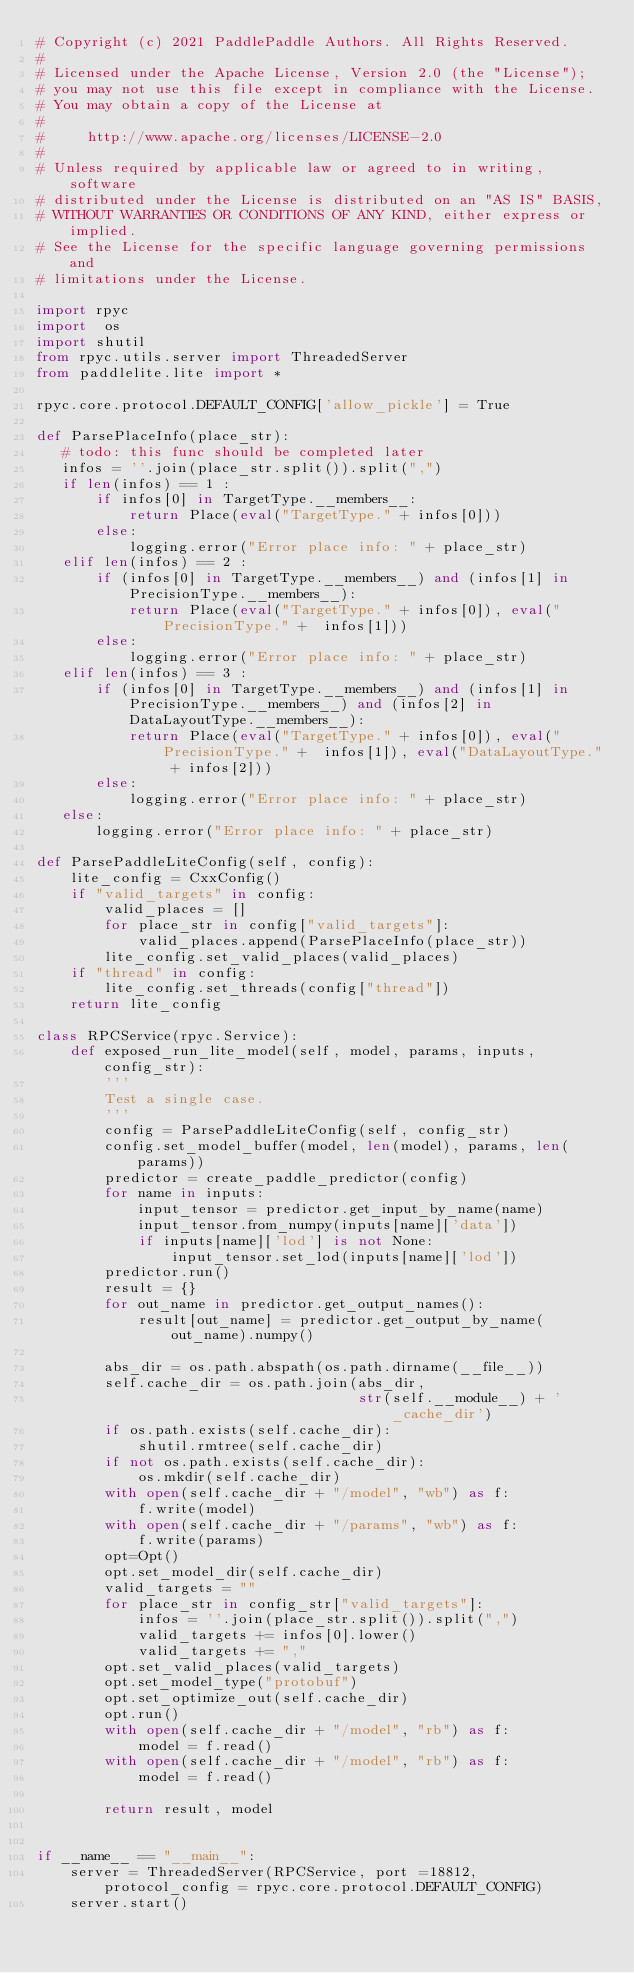Convert code to text. <code><loc_0><loc_0><loc_500><loc_500><_Python_># Copyright (c) 2021 PaddlePaddle Authors. All Rights Reserved.
#
# Licensed under the Apache License, Version 2.0 (the "License");
# you may not use this file except in compliance with the License.
# You may obtain a copy of the License at
#
#     http://www.apache.org/licenses/LICENSE-2.0
#
# Unless required by applicable law or agreed to in writing, software
# distributed under the License is distributed on an "AS IS" BASIS,
# WITHOUT WARRANTIES OR CONDITIONS OF ANY KIND, either express or implied.
# See the License for the specific language governing permissions and
# limitations under the License.

import rpyc
import  os
import shutil
from rpyc.utils.server import ThreadedServer
from paddlelite.lite import *

rpyc.core.protocol.DEFAULT_CONFIG['allow_pickle'] = True

def ParsePlaceInfo(place_str):
   # todo: this func should be completed later
   infos = ''.join(place_str.split()).split(",")
   if len(infos) == 1 :
       if infos[0] in TargetType.__members__:
           return Place(eval("TargetType." + infos[0]))
       else:
           logging.error("Error place info: " + place_str)
   elif len(infos) == 2 :
       if (infos[0] in TargetType.__members__) and (infos[1] in PrecisionType.__members__):
           return Place(eval("TargetType." + infos[0]), eval("PrecisionType." +  infos[1]))
       else:
           logging.error("Error place info: " + place_str)
   elif len(infos) == 3 :
       if (infos[0] in TargetType.__members__) and (infos[1] in PrecisionType.__members__) and (infos[2] in DataLayoutType.__members__):
           return Place(eval("TargetType." + infos[0]), eval("PrecisionType." +  infos[1]), eval("DataLayoutType." + infos[2]))
       else:
           logging.error("Error place info: " + place_str)
   else:
       logging.error("Error place info: " + place_str)

def ParsePaddleLiteConfig(self, config):
    lite_config = CxxConfig()
    if "valid_targets" in config:
        valid_places = []
        for place_str in config["valid_targets"]:
            valid_places.append(ParsePlaceInfo(place_str))
        lite_config.set_valid_places(valid_places)
    if "thread" in config:
        lite_config.set_threads(config["thread"])
    return lite_config

class RPCService(rpyc.Service):
    def exposed_run_lite_model(self, model, params, inputs, config_str):
        '''
        Test a single case.
        '''
        config = ParsePaddleLiteConfig(self, config_str)
        config.set_model_buffer(model, len(model), params, len(params))
        predictor = create_paddle_predictor(config)
        for name in inputs:
            input_tensor = predictor.get_input_by_name(name)
            input_tensor.from_numpy(inputs[name]['data'])
            if inputs[name]['lod'] is not None:
                input_tensor.set_lod(inputs[name]['lod'])
        predictor.run()
        result = {}
        for out_name in predictor.get_output_names():
            result[out_name] = predictor.get_output_by_name(out_name).numpy()

        abs_dir = os.path.abspath(os.path.dirname(__file__))
        self.cache_dir = os.path.join(abs_dir,
                                      str(self.__module__) + '_cache_dir')
        if os.path.exists(self.cache_dir):
            shutil.rmtree(self.cache_dir)
        if not os.path.exists(self.cache_dir):
            os.mkdir(self.cache_dir)
        with open(self.cache_dir + "/model", "wb") as f:
            f.write(model)
        with open(self.cache_dir + "/params", "wb") as f:
            f.write(params)
        opt=Opt()
        opt.set_model_dir(self.cache_dir)
        valid_targets = ""
        for place_str in config_str["valid_targets"]:
            infos = ''.join(place_str.split()).split(",")
            valid_targets += infos[0].lower()
            valid_targets += ","
        opt.set_valid_places(valid_targets)
        opt.set_model_type("protobuf")
        opt.set_optimize_out(self.cache_dir)
        opt.run()
        with open(self.cache_dir + "/model", "rb") as f:
            model = f.read()
        with open(self.cache_dir + "/model", "rb") as f:
            model = f.read()

        return result, model


if __name__ == "__main__":
    server = ThreadedServer(RPCService, port =18812, protocol_config = rpyc.core.protocol.DEFAULT_CONFIG)
    server.start()
</code> 